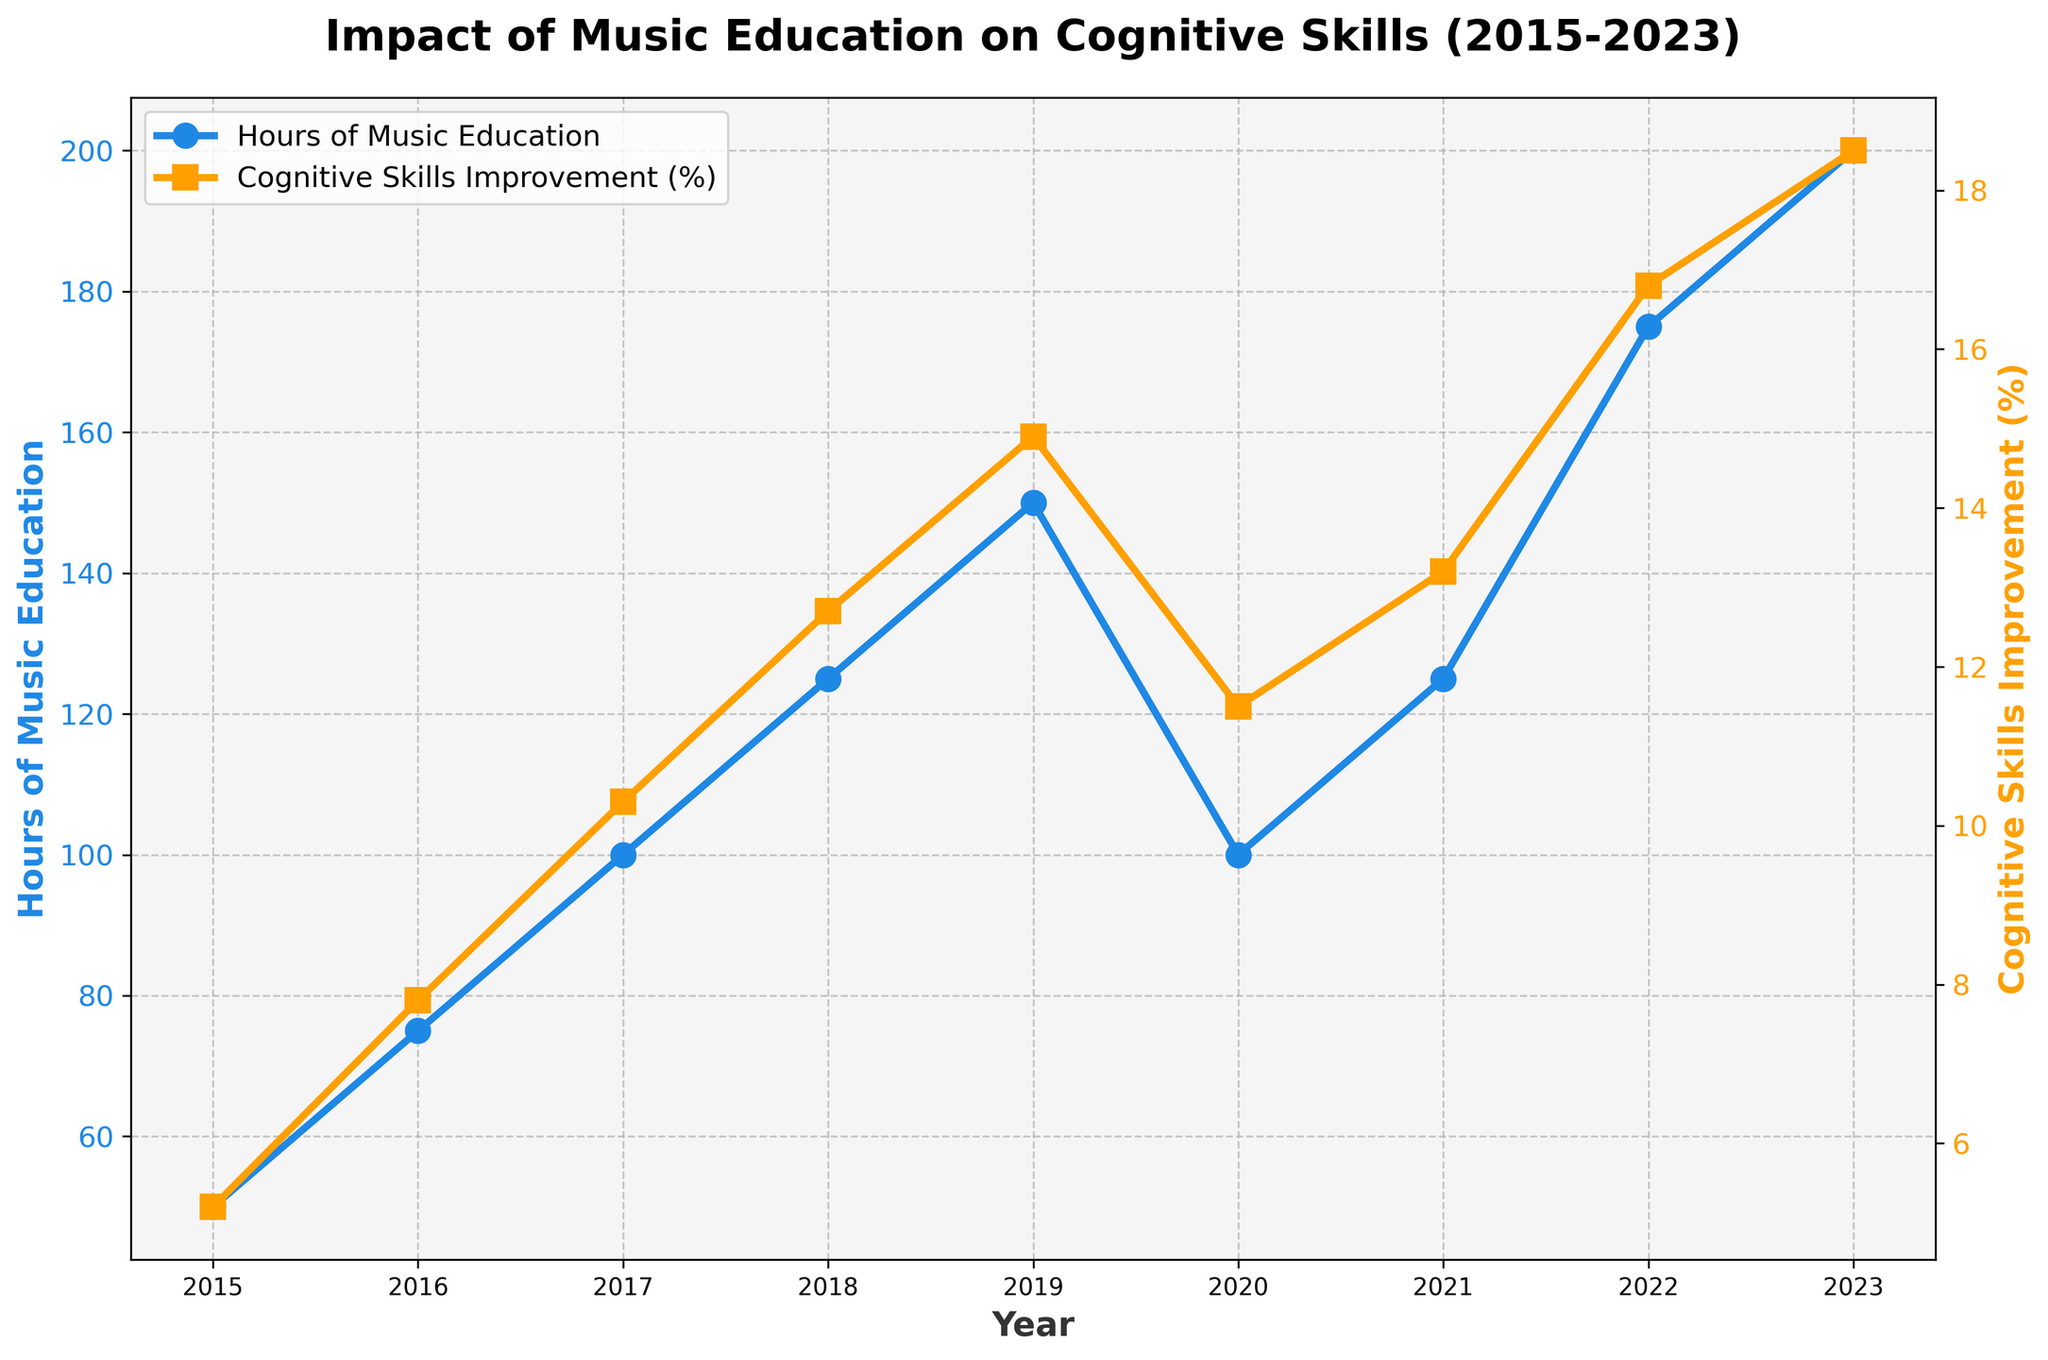What's the increase in hours of music education from 2015 to 2023? Find the hours of music education in 2023 and subtract the hours of music education in 2015. In 2023, it's 200 hours, and in 2015, it's 50 hours. So, 200 - 50 = 150 hours.
Answer: 150 hours What is the difference in cognitive skills improvement between 2018 and 2023? Find the cognitive skills improvement percentage for both years and subtract the 2018 value from the 2023 value. In 2023, it is 18.5%, and in 2018, it is 12.7%. So, 18.5% - 12.7% = 5.8%.
Answer: 5.8% Which year had the highest increase in cognitive skills improvement? Check the cognitive skills improvement percentages for each year and find the year with the maximum increase. The highest is in 2023 with 18.5%.
Answer: 2023 In which year did the hours of music education decrease from the previous year? Compare the hours of music education from each year to the previous year. The hours decreased from 2019 to 2020, dropping from 150 to 100 hours.
Answer: 2020 Between which two consecutive years was the increase in cognitive skills improvement the smallest? Calculate the year-over-year difference for cognitive skills improvement and find the smallest increment. Between 2015 to 2016, the increase was from 5.2% to 7.8%, i.e., 2.6%; between 2016 to 2017, it was from 7.8% to 10.3%, i.e., 2.5%; and so forth. The smallest increase was between 2020 and 2021, going from 11.5% to 13.2%, i.e., 1.7%.
Answer: 2020-2021 What is the overall trend in hours of music education from 2015 to 2023? By observing the line plot for hours of music education, the general trend is an increase over the years despite minor fluctuations.
Answer: Increasing What's the average cognitive skills improvement from 2015 to 2023? Sum up the cognitive skills improvement percentages from each year and divide by the number of years (9 years). The sum is (5.2 + 7.8 + 10.3 + 12.7 + 14.9 + 11.5 + 13.2 + 16.8 + 18.5) = 110.9. The average is 110.9 / 9 ≈ 12.32%.
Answer: 12.32% In which year is the cognitive skills improvement rate the lowest, and by how much is it less than the highest rate? Identify the year with the lowest rate (2015 at 5.2%) and the highest rate (2023 at 18.5%), then compute the difference: 18.5% - 5.2% = 13.3%.
Answer: 2015, 13.3% 